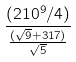<formula> <loc_0><loc_0><loc_500><loc_500>\frac { ( 2 1 0 ^ { 9 } / 4 ) } { \frac { ( \sqrt { 9 } + 3 1 7 ) } { \sqrt { 5 } } }</formula> 